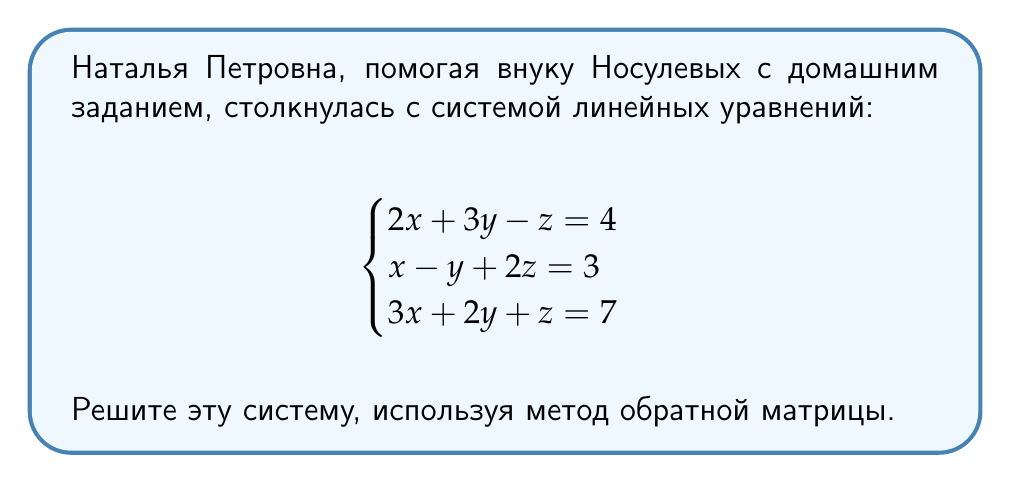Give your solution to this math problem. 1. Запишем систему в матричном виде $AX = B$:

   $$\begin{pmatrix}
   2 & 3 & -1 \\
   1 & -1 & 2 \\
   3 & 2 & 1
   \end{pmatrix}
   \begin{pmatrix}
   x \\ y \\ z
   \end{pmatrix} =
   \begin{pmatrix}
   4 \\ 3 \\ 7
   \end{pmatrix}$$

2. Найдем определитель матрицы $A$:
   $$\det(A) = 2(-1-4) + 3(2-3) + (-1)(1-6) = -10 + (-3) + 5 = -8$$

3. Найдем обратную матрицу $A^{-1}$:
   $$A^{-1} = -\frac{1}{8}
   \begin{pmatrix}
   -3 & -5 & 4 \\
   -1 & 3 & -2 \\
   -4 & -1 & 2
   \end{pmatrix}$$

4. Умножим обе части уравнения на $A^{-1}$:
   $$A^{-1}AX = A^{-1}B$$
   $$X = A^{-1}B$$

5. Выполним умножение:
   $$\begin{pmatrix}
   x \\ y \\ z
   \end{pmatrix} = -\frac{1}{8}
   \begin{pmatrix}
   -3 & -5 & 4 \\
   -1 & 3 & -2 \\
   -4 & -1 & 2
   \end{pmatrix}
   \begin{pmatrix}
   4 \\ 3 \\ 7
   \end{pmatrix}$$

   $$\begin{pmatrix}
   x \\ y \\ z
   \end{pmatrix} = -\frac{1}{8}
   \begin{pmatrix}
   (-3)(4) + (-5)(3) + 4(7) \\
   (-1)(4) + 3(3) + (-2)(7) \\
   (-4)(4) + (-1)(3) + 2(7)
   \end{pmatrix}$$

   $$\begin{pmatrix}
   x \\ y \\ z
   \end{pmatrix} = -\frac{1}{8}
   \begin{pmatrix}
   -12 - 15 + 28 \\
   -4 + 9 - 14 \\
   -16 - 3 + 14
   \end{pmatrix} =
   \begin{pmatrix}
   \frac{1}{8} \\
   \frac{9}{8} \\
   \frac{5}{8}
   \end{pmatrix}$$
Answer: $x = \frac{1}{8}$, $y = \frac{9}{8}$, $z = \frac{5}{8}$ 